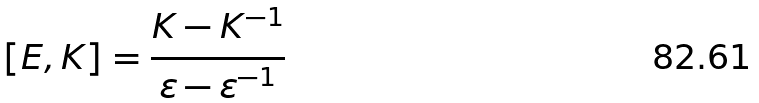<formula> <loc_0><loc_0><loc_500><loc_500>[ E , K ] = \frac { K - K ^ { - 1 } } { \varepsilon - \varepsilon ^ { - 1 } }</formula> 